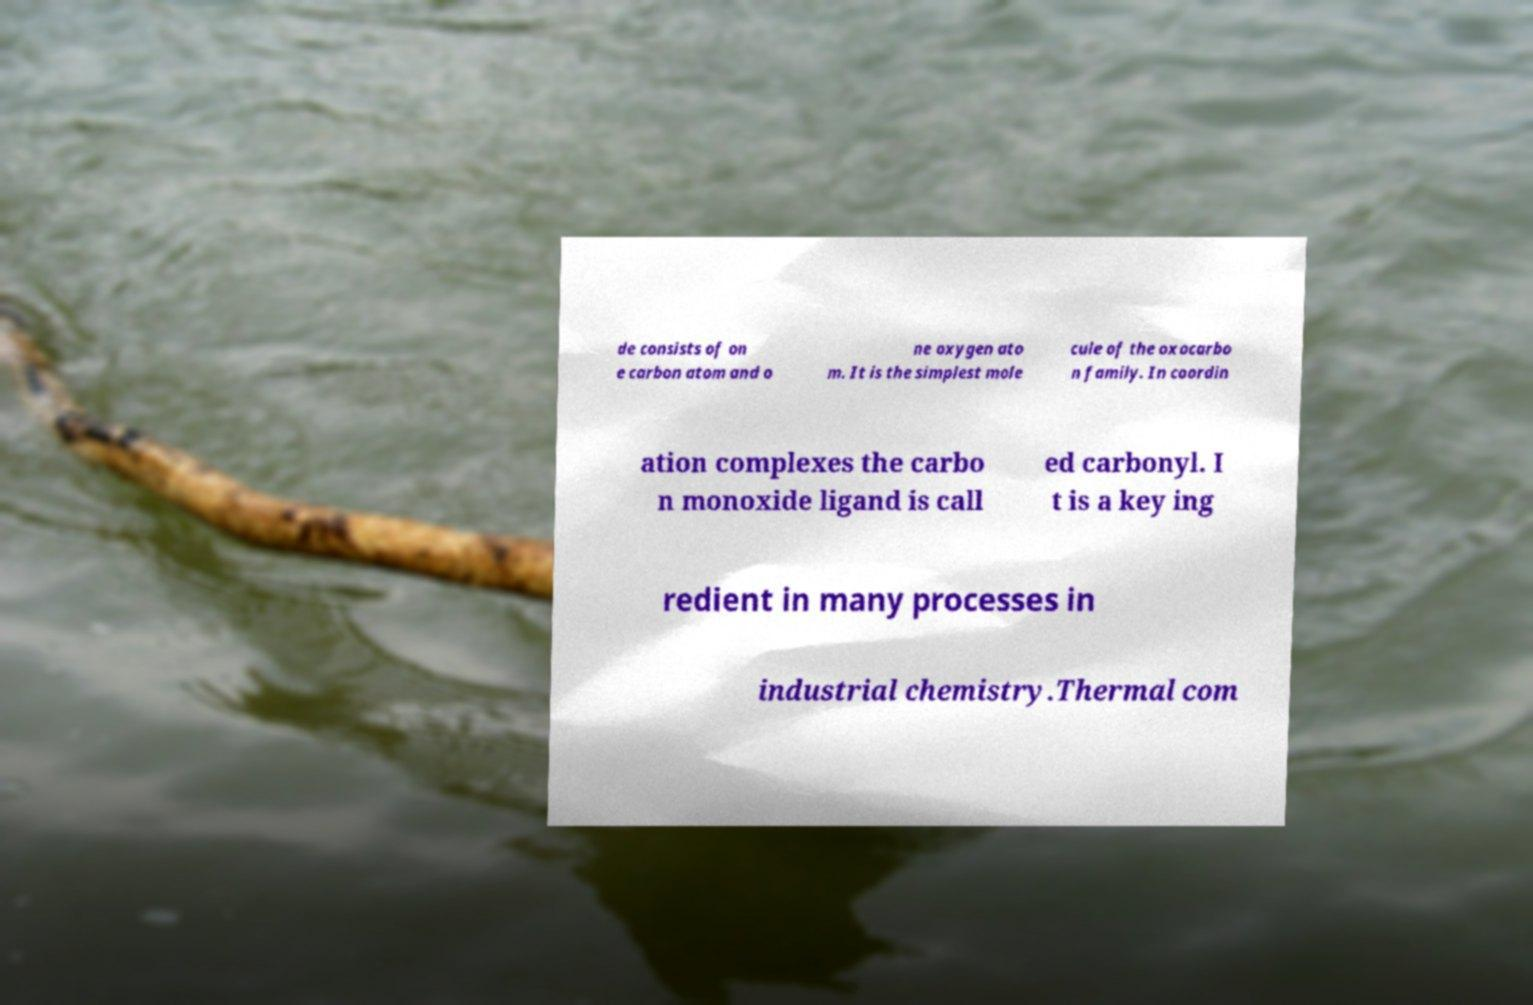Can you read and provide the text displayed in the image?This photo seems to have some interesting text. Can you extract and type it out for me? de consists of on e carbon atom and o ne oxygen ato m. It is the simplest mole cule of the oxocarbo n family. In coordin ation complexes the carbo n monoxide ligand is call ed carbonyl. I t is a key ing redient in many processes in industrial chemistry.Thermal com 